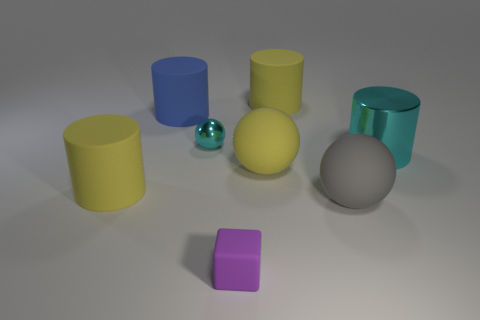How many other objects are there of the same size as the blue rubber cylinder?
Your response must be concise. 5. What number of things are rubber cubes or yellow things behind the small purple block?
Provide a short and direct response. 4. Are there an equal number of big yellow matte things to the left of the small purple rubber cube and big cylinders?
Your response must be concise. No. There is a small thing that is made of the same material as the large gray thing; what shape is it?
Your answer should be very brief. Cube. Is there another cylinder of the same color as the big shiny cylinder?
Your answer should be very brief. No. How many metallic objects are either large cylinders or small purple cubes?
Provide a succinct answer. 1. How many small cyan balls are behind the big yellow rubber thing that is behind the metallic cylinder?
Your answer should be compact. 0. What number of big cyan things have the same material as the small cyan sphere?
Offer a terse response. 1. What number of large things are shiny spheres or rubber cubes?
Offer a terse response. 0. There is a large matte object that is both on the right side of the blue rubber object and in front of the yellow matte sphere; what shape is it?
Keep it short and to the point. Sphere. 